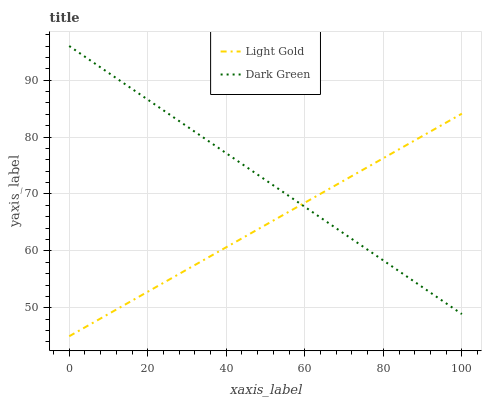Does Dark Green have the minimum area under the curve?
Answer yes or no. No. Is Dark Green the roughest?
Answer yes or no. No. Does Dark Green have the lowest value?
Answer yes or no. No. 